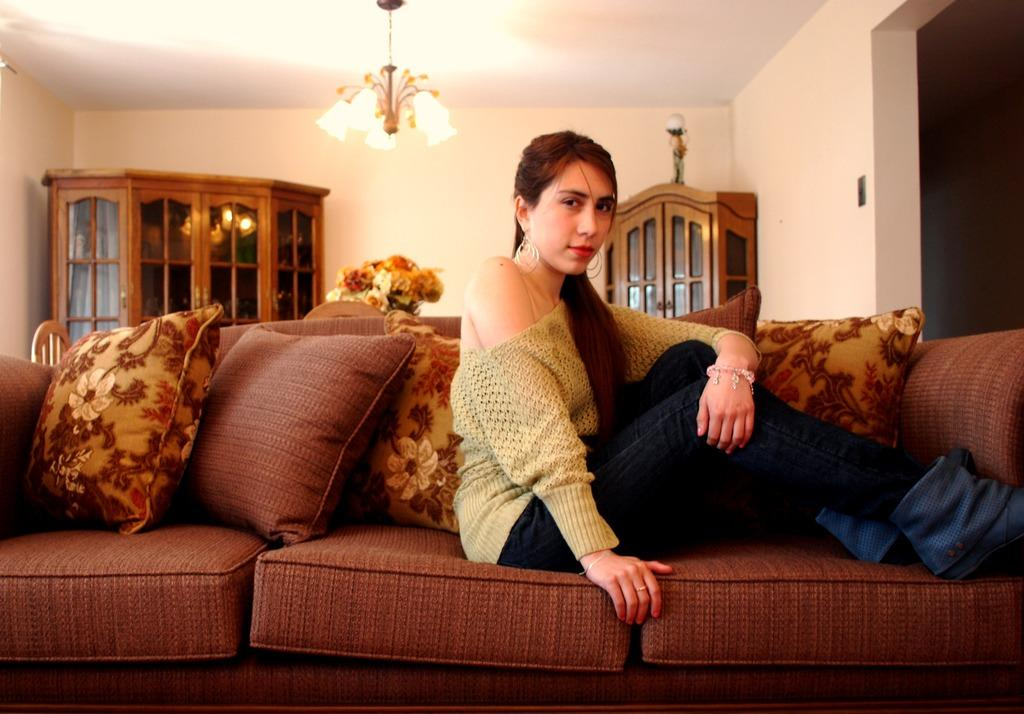What is the woman doing in the image? The woman is sitting on a couch in the image. What can be seen on the couch besides the woman? There are pillows on the couch. What objects are visible at the back side of the image? There is a chair, a flower pot, and a cupboard at the back side of the image. What type of cherry is the woman holding in the image? There is no cherry present in the image; the woman is sitting on a couch with pillows. 